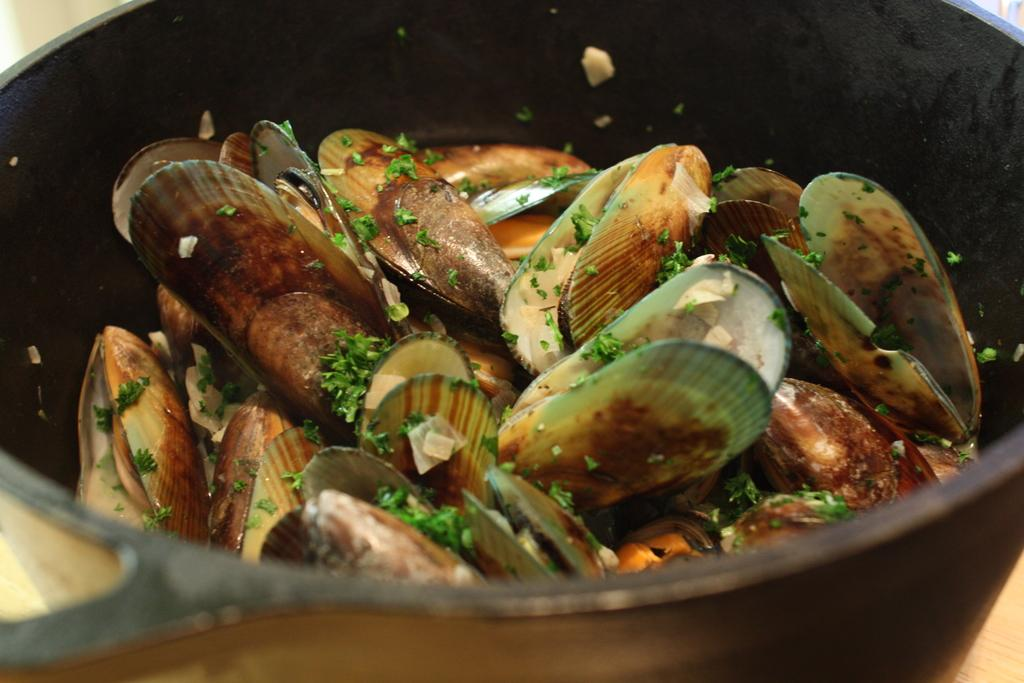What objects are on the pan in the image? There are leaves and shells on a pan in the image. Can you describe the background of the image? The background of the image is blurred. What type of cattle can be seen grazing in the background of the image? There are no cattle present in the image; the background is blurred. What suggestion is being made by the flower in the image? There is no flower present in the image, so no suggestion can be made. 